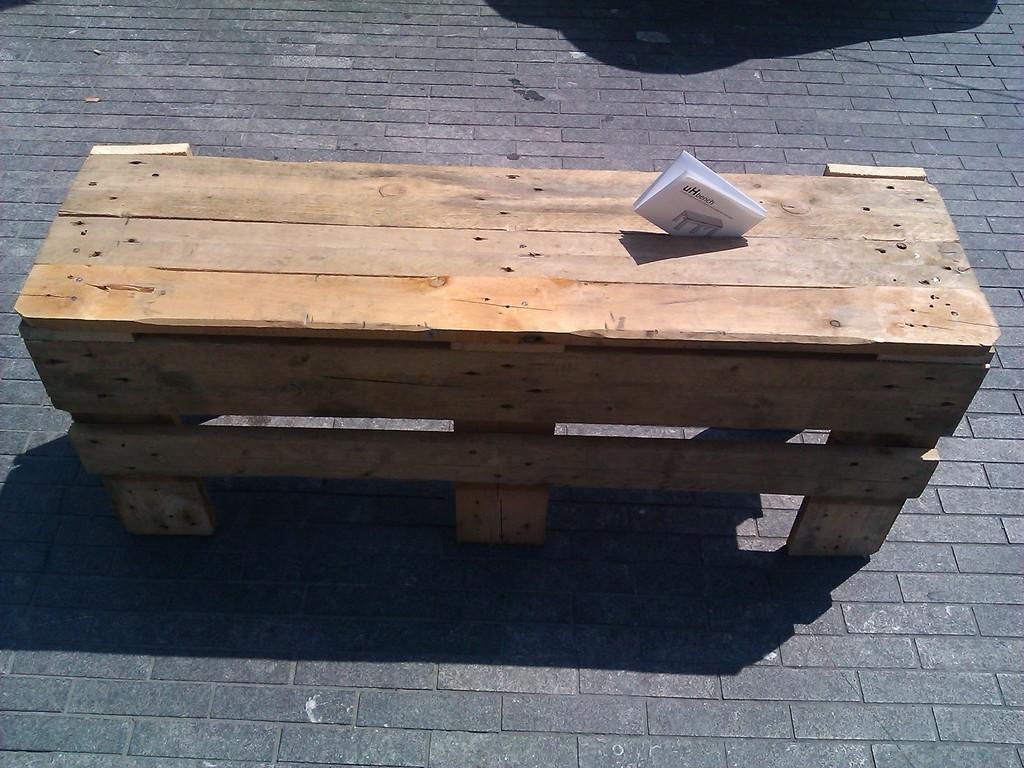Describe this image in one or two sentences. There is a wooden bench and a paper in the foreground area of the image and a shadow at the top side. 